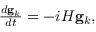Convert formula to latex. <formula><loc_0><loc_0><loc_500><loc_500>\begin{array} { r } { \frac { d g _ { k } } { d t } = - i H g _ { k } , } \end{array}</formula> 